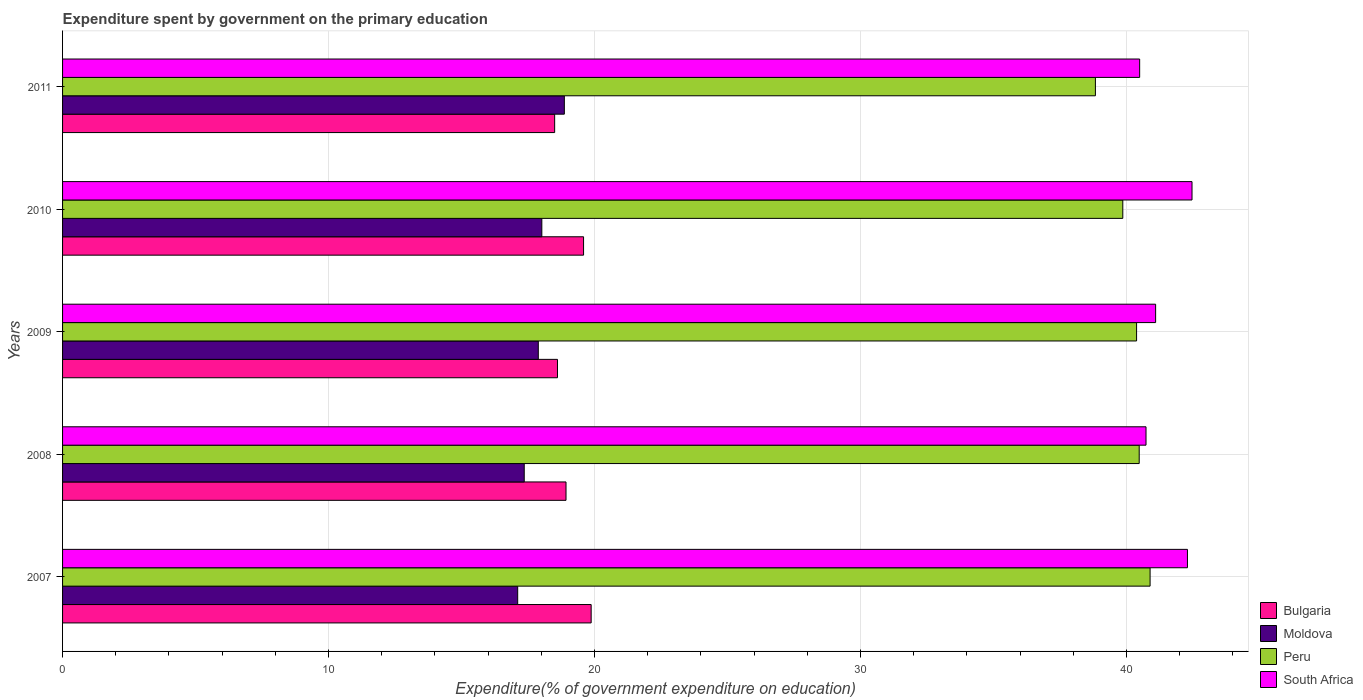How many groups of bars are there?
Give a very brief answer. 5. How many bars are there on the 2nd tick from the top?
Make the answer very short. 4. What is the expenditure spent by government on the primary education in South Africa in 2009?
Provide a short and direct response. 41.09. Across all years, what is the maximum expenditure spent by government on the primary education in South Africa?
Offer a very short reply. 42.46. Across all years, what is the minimum expenditure spent by government on the primary education in South Africa?
Your response must be concise. 40.49. In which year was the expenditure spent by government on the primary education in Moldova maximum?
Your answer should be compact. 2011. In which year was the expenditure spent by government on the primary education in Bulgaria minimum?
Provide a short and direct response. 2011. What is the total expenditure spent by government on the primary education in Peru in the graph?
Offer a terse response. 200.43. What is the difference between the expenditure spent by government on the primary education in Bulgaria in 2007 and that in 2009?
Give a very brief answer. 1.27. What is the difference between the expenditure spent by government on the primary education in Peru in 2009 and the expenditure spent by government on the primary education in Bulgaria in 2008?
Your answer should be very brief. 21.45. What is the average expenditure spent by government on the primary education in Peru per year?
Ensure brevity in your answer.  40.09. In the year 2011, what is the difference between the expenditure spent by government on the primary education in Moldova and expenditure spent by government on the primary education in Peru?
Make the answer very short. -19.97. What is the ratio of the expenditure spent by government on the primary education in South Africa in 2007 to that in 2011?
Keep it short and to the point. 1.04. Is the expenditure spent by government on the primary education in Moldova in 2007 less than that in 2008?
Ensure brevity in your answer.  Yes. Is the difference between the expenditure spent by government on the primary education in Moldova in 2009 and 2011 greater than the difference between the expenditure spent by government on the primary education in Peru in 2009 and 2011?
Provide a short and direct response. No. What is the difference between the highest and the second highest expenditure spent by government on the primary education in Bulgaria?
Give a very brief answer. 0.29. What is the difference between the highest and the lowest expenditure spent by government on the primary education in Moldova?
Your response must be concise. 1.75. What does the 4th bar from the top in 2008 represents?
Give a very brief answer. Bulgaria. What does the 4th bar from the bottom in 2011 represents?
Offer a terse response. South Africa. Is it the case that in every year, the sum of the expenditure spent by government on the primary education in Moldova and expenditure spent by government on the primary education in Peru is greater than the expenditure spent by government on the primary education in Bulgaria?
Make the answer very short. Yes. How many bars are there?
Provide a short and direct response. 20. Are all the bars in the graph horizontal?
Offer a very short reply. Yes. How many years are there in the graph?
Give a very brief answer. 5. What is the difference between two consecutive major ticks on the X-axis?
Offer a terse response. 10. Are the values on the major ticks of X-axis written in scientific E-notation?
Make the answer very short. No. Does the graph contain grids?
Make the answer very short. Yes. Where does the legend appear in the graph?
Your answer should be very brief. Bottom right. How are the legend labels stacked?
Offer a very short reply. Vertical. What is the title of the graph?
Your response must be concise. Expenditure spent by government on the primary education. What is the label or title of the X-axis?
Offer a terse response. Expenditure(% of government expenditure on education). What is the label or title of the Y-axis?
Your answer should be very brief. Years. What is the Expenditure(% of government expenditure on education) in Bulgaria in 2007?
Give a very brief answer. 19.87. What is the Expenditure(% of government expenditure on education) of Moldova in 2007?
Give a very brief answer. 17.11. What is the Expenditure(% of government expenditure on education) of Peru in 2007?
Your answer should be very brief. 40.89. What is the Expenditure(% of government expenditure on education) in South Africa in 2007?
Ensure brevity in your answer.  42.29. What is the Expenditure(% of government expenditure on education) of Bulgaria in 2008?
Ensure brevity in your answer.  18.93. What is the Expenditure(% of government expenditure on education) of Moldova in 2008?
Make the answer very short. 17.36. What is the Expenditure(% of government expenditure on education) of Peru in 2008?
Your answer should be compact. 40.48. What is the Expenditure(% of government expenditure on education) in South Africa in 2008?
Keep it short and to the point. 40.73. What is the Expenditure(% of government expenditure on education) of Bulgaria in 2009?
Ensure brevity in your answer.  18.61. What is the Expenditure(% of government expenditure on education) of Moldova in 2009?
Your response must be concise. 17.89. What is the Expenditure(% of government expenditure on education) of Peru in 2009?
Offer a terse response. 40.38. What is the Expenditure(% of government expenditure on education) in South Africa in 2009?
Provide a short and direct response. 41.09. What is the Expenditure(% of government expenditure on education) of Bulgaria in 2010?
Your response must be concise. 19.59. What is the Expenditure(% of government expenditure on education) in Moldova in 2010?
Your answer should be very brief. 18.02. What is the Expenditure(% of government expenditure on education) of Peru in 2010?
Provide a short and direct response. 39.86. What is the Expenditure(% of government expenditure on education) of South Africa in 2010?
Offer a very short reply. 42.46. What is the Expenditure(% of government expenditure on education) of Bulgaria in 2011?
Your response must be concise. 18.5. What is the Expenditure(% of government expenditure on education) of Moldova in 2011?
Provide a succinct answer. 18.87. What is the Expenditure(% of government expenditure on education) of Peru in 2011?
Ensure brevity in your answer.  38.83. What is the Expenditure(% of government expenditure on education) in South Africa in 2011?
Keep it short and to the point. 40.49. Across all years, what is the maximum Expenditure(% of government expenditure on education) in Bulgaria?
Your response must be concise. 19.87. Across all years, what is the maximum Expenditure(% of government expenditure on education) of Moldova?
Offer a very short reply. 18.87. Across all years, what is the maximum Expenditure(% of government expenditure on education) of Peru?
Provide a succinct answer. 40.89. Across all years, what is the maximum Expenditure(% of government expenditure on education) in South Africa?
Offer a terse response. 42.46. Across all years, what is the minimum Expenditure(% of government expenditure on education) in Bulgaria?
Offer a very short reply. 18.5. Across all years, what is the minimum Expenditure(% of government expenditure on education) in Moldova?
Your response must be concise. 17.11. Across all years, what is the minimum Expenditure(% of government expenditure on education) of Peru?
Ensure brevity in your answer.  38.83. Across all years, what is the minimum Expenditure(% of government expenditure on education) of South Africa?
Your response must be concise. 40.49. What is the total Expenditure(% of government expenditure on education) in Bulgaria in the graph?
Keep it short and to the point. 95.5. What is the total Expenditure(% of government expenditure on education) of Moldova in the graph?
Your response must be concise. 89.24. What is the total Expenditure(% of government expenditure on education) of Peru in the graph?
Offer a very short reply. 200.43. What is the total Expenditure(% of government expenditure on education) of South Africa in the graph?
Your answer should be compact. 207.08. What is the difference between the Expenditure(% of government expenditure on education) in Bulgaria in 2007 and that in 2008?
Give a very brief answer. 0.95. What is the difference between the Expenditure(% of government expenditure on education) of Moldova in 2007 and that in 2008?
Make the answer very short. -0.25. What is the difference between the Expenditure(% of government expenditure on education) in Peru in 2007 and that in 2008?
Provide a short and direct response. 0.41. What is the difference between the Expenditure(% of government expenditure on education) in South Africa in 2007 and that in 2008?
Make the answer very short. 1.56. What is the difference between the Expenditure(% of government expenditure on education) of Bulgaria in 2007 and that in 2009?
Provide a short and direct response. 1.27. What is the difference between the Expenditure(% of government expenditure on education) of Moldova in 2007 and that in 2009?
Provide a short and direct response. -0.77. What is the difference between the Expenditure(% of government expenditure on education) of Peru in 2007 and that in 2009?
Offer a terse response. 0.51. What is the difference between the Expenditure(% of government expenditure on education) of South Africa in 2007 and that in 2009?
Your response must be concise. 1.2. What is the difference between the Expenditure(% of government expenditure on education) in Bulgaria in 2007 and that in 2010?
Offer a terse response. 0.29. What is the difference between the Expenditure(% of government expenditure on education) of Moldova in 2007 and that in 2010?
Make the answer very short. -0.91. What is the difference between the Expenditure(% of government expenditure on education) of Peru in 2007 and that in 2010?
Provide a succinct answer. 1.03. What is the difference between the Expenditure(% of government expenditure on education) in South Africa in 2007 and that in 2010?
Offer a very short reply. -0.17. What is the difference between the Expenditure(% of government expenditure on education) of Bulgaria in 2007 and that in 2011?
Your answer should be very brief. 1.37. What is the difference between the Expenditure(% of government expenditure on education) in Moldova in 2007 and that in 2011?
Provide a succinct answer. -1.75. What is the difference between the Expenditure(% of government expenditure on education) of Peru in 2007 and that in 2011?
Your answer should be very brief. 2.06. What is the difference between the Expenditure(% of government expenditure on education) in South Africa in 2007 and that in 2011?
Provide a short and direct response. 1.8. What is the difference between the Expenditure(% of government expenditure on education) of Bulgaria in 2008 and that in 2009?
Your response must be concise. 0.32. What is the difference between the Expenditure(% of government expenditure on education) of Moldova in 2008 and that in 2009?
Provide a short and direct response. -0.53. What is the difference between the Expenditure(% of government expenditure on education) of Peru in 2008 and that in 2009?
Keep it short and to the point. 0.1. What is the difference between the Expenditure(% of government expenditure on education) of South Africa in 2008 and that in 2009?
Give a very brief answer. -0.36. What is the difference between the Expenditure(% of government expenditure on education) of Bulgaria in 2008 and that in 2010?
Make the answer very short. -0.66. What is the difference between the Expenditure(% of government expenditure on education) in Moldova in 2008 and that in 2010?
Ensure brevity in your answer.  -0.66. What is the difference between the Expenditure(% of government expenditure on education) in Peru in 2008 and that in 2010?
Provide a succinct answer. 0.62. What is the difference between the Expenditure(% of government expenditure on education) of South Africa in 2008 and that in 2010?
Your response must be concise. -1.73. What is the difference between the Expenditure(% of government expenditure on education) of Bulgaria in 2008 and that in 2011?
Offer a terse response. 0.43. What is the difference between the Expenditure(% of government expenditure on education) of Moldova in 2008 and that in 2011?
Provide a short and direct response. -1.51. What is the difference between the Expenditure(% of government expenditure on education) of Peru in 2008 and that in 2011?
Give a very brief answer. 1.65. What is the difference between the Expenditure(% of government expenditure on education) in South Africa in 2008 and that in 2011?
Offer a very short reply. 0.24. What is the difference between the Expenditure(% of government expenditure on education) of Bulgaria in 2009 and that in 2010?
Your answer should be very brief. -0.98. What is the difference between the Expenditure(% of government expenditure on education) in Moldova in 2009 and that in 2010?
Provide a succinct answer. -0.13. What is the difference between the Expenditure(% of government expenditure on education) of Peru in 2009 and that in 2010?
Make the answer very short. 0.52. What is the difference between the Expenditure(% of government expenditure on education) of South Africa in 2009 and that in 2010?
Your answer should be very brief. -1.37. What is the difference between the Expenditure(% of government expenditure on education) of Bulgaria in 2009 and that in 2011?
Make the answer very short. 0.11. What is the difference between the Expenditure(% of government expenditure on education) in Moldova in 2009 and that in 2011?
Your answer should be compact. -0.98. What is the difference between the Expenditure(% of government expenditure on education) of Peru in 2009 and that in 2011?
Keep it short and to the point. 1.55. What is the difference between the Expenditure(% of government expenditure on education) of South Africa in 2009 and that in 2011?
Provide a succinct answer. 0.6. What is the difference between the Expenditure(% of government expenditure on education) in Bulgaria in 2010 and that in 2011?
Keep it short and to the point. 1.09. What is the difference between the Expenditure(% of government expenditure on education) of Moldova in 2010 and that in 2011?
Offer a terse response. -0.85. What is the difference between the Expenditure(% of government expenditure on education) in Peru in 2010 and that in 2011?
Your answer should be very brief. 1.03. What is the difference between the Expenditure(% of government expenditure on education) in South Africa in 2010 and that in 2011?
Provide a short and direct response. 1.97. What is the difference between the Expenditure(% of government expenditure on education) of Bulgaria in 2007 and the Expenditure(% of government expenditure on education) of Moldova in 2008?
Your response must be concise. 2.52. What is the difference between the Expenditure(% of government expenditure on education) of Bulgaria in 2007 and the Expenditure(% of government expenditure on education) of Peru in 2008?
Make the answer very short. -20.6. What is the difference between the Expenditure(% of government expenditure on education) of Bulgaria in 2007 and the Expenditure(% of government expenditure on education) of South Africa in 2008?
Ensure brevity in your answer.  -20.86. What is the difference between the Expenditure(% of government expenditure on education) of Moldova in 2007 and the Expenditure(% of government expenditure on education) of Peru in 2008?
Give a very brief answer. -23.37. What is the difference between the Expenditure(% of government expenditure on education) in Moldova in 2007 and the Expenditure(% of government expenditure on education) in South Africa in 2008?
Make the answer very short. -23.62. What is the difference between the Expenditure(% of government expenditure on education) of Peru in 2007 and the Expenditure(% of government expenditure on education) of South Africa in 2008?
Provide a short and direct response. 0.15. What is the difference between the Expenditure(% of government expenditure on education) of Bulgaria in 2007 and the Expenditure(% of government expenditure on education) of Moldova in 2009?
Ensure brevity in your answer.  1.99. What is the difference between the Expenditure(% of government expenditure on education) in Bulgaria in 2007 and the Expenditure(% of government expenditure on education) in Peru in 2009?
Provide a succinct answer. -20.51. What is the difference between the Expenditure(% of government expenditure on education) of Bulgaria in 2007 and the Expenditure(% of government expenditure on education) of South Africa in 2009?
Keep it short and to the point. -21.22. What is the difference between the Expenditure(% of government expenditure on education) of Moldova in 2007 and the Expenditure(% of government expenditure on education) of Peru in 2009?
Provide a succinct answer. -23.27. What is the difference between the Expenditure(% of government expenditure on education) in Moldova in 2007 and the Expenditure(% of government expenditure on education) in South Africa in 2009?
Ensure brevity in your answer.  -23.98. What is the difference between the Expenditure(% of government expenditure on education) in Peru in 2007 and the Expenditure(% of government expenditure on education) in South Africa in 2009?
Ensure brevity in your answer.  -0.21. What is the difference between the Expenditure(% of government expenditure on education) of Bulgaria in 2007 and the Expenditure(% of government expenditure on education) of Moldova in 2010?
Ensure brevity in your answer.  1.85. What is the difference between the Expenditure(% of government expenditure on education) in Bulgaria in 2007 and the Expenditure(% of government expenditure on education) in Peru in 2010?
Make the answer very short. -19.99. What is the difference between the Expenditure(% of government expenditure on education) of Bulgaria in 2007 and the Expenditure(% of government expenditure on education) of South Africa in 2010?
Ensure brevity in your answer.  -22.59. What is the difference between the Expenditure(% of government expenditure on education) in Moldova in 2007 and the Expenditure(% of government expenditure on education) in Peru in 2010?
Give a very brief answer. -22.75. What is the difference between the Expenditure(% of government expenditure on education) in Moldova in 2007 and the Expenditure(% of government expenditure on education) in South Africa in 2010?
Your response must be concise. -25.35. What is the difference between the Expenditure(% of government expenditure on education) of Peru in 2007 and the Expenditure(% of government expenditure on education) of South Africa in 2010?
Ensure brevity in your answer.  -1.58. What is the difference between the Expenditure(% of government expenditure on education) of Bulgaria in 2007 and the Expenditure(% of government expenditure on education) of Peru in 2011?
Ensure brevity in your answer.  -18.96. What is the difference between the Expenditure(% of government expenditure on education) of Bulgaria in 2007 and the Expenditure(% of government expenditure on education) of South Africa in 2011?
Your answer should be compact. -20.62. What is the difference between the Expenditure(% of government expenditure on education) of Moldova in 2007 and the Expenditure(% of government expenditure on education) of Peru in 2011?
Make the answer very short. -21.72. What is the difference between the Expenditure(% of government expenditure on education) in Moldova in 2007 and the Expenditure(% of government expenditure on education) in South Africa in 2011?
Keep it short and to the point. -23.38. What is the difference between the Expenditure(% of government expenditure on education) in Peru in 2007 and the Expenditure(% of government expenditure on education) in South Africa in 2011?
Your answer should be very brief. 0.39. What is the difference between the Expenditure(% of government expenditure on education) in Bulgaria in 2008 and the Expenditure(% of government expenditure on education) in Moldova in 2009?
Your answer should be compact. 1.04. What is the difference between the Expenditure(% of government expenditure on education) in Bulgaria in 2008 and the Expenditure(% of government expenditure on education) in Peru in 2009?
Keep it short and to the point. -21.45. What is the difference between the Expenditure(% of government expenditure on education) in Bulgaria in 2008 and the Expenditure(% of government expenditure on education) in South Africa in 2009?
Offer a terse response. -22.17. What is the difference between the Expenditure(% of government expenditure on education) of Moldova in 2008 and the Expenditure(% of government expenditure on education) of Peru in 2009?
Ensure brevity in your answer.  -23.02. What is the difference between the Expenditure(% of government expenditure on education) of Moldova in 2008 and the Expenditure(% of government expenditure on education) of South Africa in 2009?
Your answer should be compact. -23.74. What is the difference between the Expenditure(% of government expenditure on education) of Peru in 2008 and the Expenditure(% of government expenditure on education) of South Africa in 2009?
Give a very brief answer. -0.62. What is the difference between the Expenditure(% of government expenditure on education) of Bulgaria in 2008 and the Expenditure(% of government expenditure on education) of Moldova in 2010?
Offer a terse response. 0.91. What is the difference between the Expenditure(% of government expenditure on education) in Bulgaria in 2008 and the Expenditure(% of government expenditure on education) in Peru in 2010?
Keep it short and to the point. -20.93. What is the difference between the Expenditure(% of government expenditure on education) of Bulgaria in 2008 and the Expenditure(% of government expenditure on education) of South Africa in 2010?
Your response must be concise. -23.54. What is the difference between the Expenditure(% of government expenditure on education) in Moldova in 2008 and the Expenditure(% of government expenditure on education) in Peru in 2010?
Give a very brief answer. -22.5. What is the difference between the Expenditure(% of government expenditure on education) in Moldova in 2008 and the Expenditure(% of government expenditure on education) in South Africa in 2010?
Keep it short and to the point. -25.11. What is the difference between the Expenditure(% of government expenditure on education) in Peru in 2008 and the Expenditure(% of government expenditure on education) in South Africa in 2010?
Ensure brevity in your answer.  -1.99. What is the difference between the Expenditure(% of government expenditure on education) in Bulgaria in 2008 and the Expenditure(% of government expenditure on education) in Moldova in 2011?
Provide a short and direct response. 0.06. What is the difference between the Expenditure(% of government expenditure on education) in Bulgaria in 2008 and the Expenditure(% of government expenditure on education) in Peru in 2011?
Offer a very short reply. -19.9. What is the difference between the Expenditure(% of government expenditure on education) of Bulgaria in 2008 and the Expenditure(% of government expenditure on education) of South Africa in 2011?
Make the answer very short. -21.57. What is the difference between the Expenditure(% of government expenditure on education) of Moldova in 2008 and the Expenditure(% of government expenditure on education) of Peru in 2011?
Ensure brevity in your answer.  -21.47. What is the difference between the Expenditure(% of government expenditure on education) of Moldova in 2008 and the Expenditure(% of government expenditure on education) of South Africa in 2011?
Provide a succinct answer. -23.14. What is the difference between the Expenditure(% of government expenditure on education) in Peru in 2008 and the Expenditure(% of government expenditure on education) in South Africa in 2011?
Offer a terse response. -0.02. What is the difference between the Expenditure(% of government expenditure on education) in Bulgaria in 2009 and the Expenditure(% of government expenditure on education) in Moldova in 2010?
Keep it short and to the point. 0.59. What is the difference between the Expenditure(% of government expenditure on education) of Bulgaria in 2009 and the Expenditure(% of government expenditure on education) of Peru in 2010?
Keep it short and to the point. -21.25. What is the difference between the Expenditure(% of government expenditure on education) of Bulgaria in 2009 and the Expenditure(% of government expenditure on education) of South Africa in 2010?
Your answer should be compact. -23.86. What is the difference between the Expenditure(% of government expenditure on education) in Moldova in 2009 and the Expenditure(% of government expenditure on education) in Peru in 2010?
Make the answer very short. -21.97. What is the difference between the Expenditure(% of government expenditure on education) of Moldova in 2009 and the Expenditure(% of government expenditure on education) of South Africa in 2010?
Ensure brevity in your answer.  -24.58. What is the difference between the Expenditure(% of government expenditure on education) in Peru in 2009 and the Expenditure(% of government expenditure on education) in South Africa in 2010?
Provide a succinct answer. -2.08. What is the difference between the Expenditure(% of government expenditure on education) of Bulgaria in 2009 and the Expenditure(% of government expenditure on education) of Moldova in 2011?
Make the answer very short. -0.26. What is the difference between the Expenditure(% of government expenditure on education) in Bulgaria in 2009 and the Expenditure(% of government expenditure on education) in Peru in 2011?
Provide a succinct answer. -20.22. What is the difference between the Expenditure(% of government expenditure on education) in Bulgaria in 2009 and the Expenditure(% of government expenditure on education) in South Africa in 2011?
Your answer should be compact. -21.89. What is the difference between the Expenditure(% of government expenditure on education) of Moldova in 2009 and the Expenditure(% of government expenditure on education) of Peru in 2011?
Your response must be concise. -20.94. What is the difference between the Expenditure(% of government expenditure on education) of Moldova in 2009 and the Expenditure(% of government expenditure on education) of South Africa in 2011?
Give a very brief answer. -22.61. What is the difference between the Expenditure(% of government expenditure on education) in Peru in 2009 and the Expenditure(% of government expenditure on education) in South Africa in 2011?
Your answer should be compact. -0.12. What is the difference between the Expenditure(% of government expenditure on education) of Bulgaria in 2010 and the Expenditure(% of government expenditure on education) of Moldova in 2011?
Offer a terse response. 0.72. What is the difference between the Expenditure(% of government expenditure on education) in Bulgaria in 2010 and the Expenditure(% of government expenditure on education) in Peru in 2011?
Your answer should be compact. -19.24. What is the difference between the Expenditure(% of government expenditure on education) of Bulgaria in 2010 and the Expenditure(% of government expenditure on education) of South Africa in 2011?
Keep it short and to the point. -20.91. What is the difference between the Expenditure(% of government expenditure on education) in Moldova in 2010 and the Expenditure(% of government expenditure on education) in Peru in 2011?
Give a very brief answer. -20.81. What is the difference between the Expenditure(% of government expenditure on education) in Moldova in 2010 and the Expenditure(% of government expenditure on education) in South Africa in 2011?
Your answer should be compact. -22.48. What is the difference between the Expenditure(% of government expenditure on education) of Peru in 2010 and the Expenditure(% of government expenditure on education) of South Africa in 2011?
Offer a very short reply. -0.63. What is the average Expenditure(% of government expenditure on education) in Bulgaria per year?
Give a very brief answer. 19.1. What is the average Expenditure(% of government expenditure on education) in Moldova per year?
Keep it short and to the point. 17.85. What is the average Expenditure(% of government expenditure on education) in Peru per year?
Make the answer very short. 40.09. What is the average Expenditure(% of government expenditure on education) in South Africa per year?
Your answer should be compact. 41.42. In the year 2007, what is the difference between the Expenditure(% of government expenditure on education) of Bulgaria and Expenditure(% of government expenditure on education) of Moldova?
Give a very brief answer. 2.76. In the year 2007, what is the difference between the Expenditure(% of government expenditure on education) of Bulgaria and Expenditure(% of government expenditure on education) of Peru?
Provide a succinct answer. -21.01. In the year 2007, what is the difference between the Expenditure(% of government expenditure on education) of Bulgaria and Expenditure(% of government expenditure on education) of South Africa?
Ensure brevity in your answer.  -22.42. In the year 2007, what is the difference between the Expenditure(% of government expenditure on education) in Moldova and Expenditure(% of government expenditure on education) in Peru?
Provide a succinct answer. -23.78. In the year 2007, what is the difference between the Expenditure(% of government expenditure on education) of Moldova and Expenditure(% of government expenditure on education) of South Africa?
Offer a very short reply. -25.18. In the year 2007, what is the difference between the Expenditure(% of government expenditure on education) in Peru and Expenditure(% of government expenditure on education) in South Africa?
Make the answer very short. -1.41. In the year 2008, what is the difference between the Expenditure(% of government expenditure on education) of Bulgaria and Expenditure(% of government expenditure on education) of Moldova?
Make the answer very short. 1.57. In the year 2008, what is the difference between the Expenditure(% of government expenditure on education) in Bulgaria and Expenditure(% of government expenditure on education) in Peru?
Make the answer very short. -21.55. In the year 2008, what is the difference between the Expenditure(% of government expenditure on education) of Bulgaria and Expenditure(% of government expenditure on education) of South Africa?
Your response must be concise. -21.81. In the year 2008, what is the difference between the Expenditure(% of government expenditure on education) in Moldova and Expenditure(% of government expenditure on education) in Peru?
Make the answer very short. -23.12. In the year 2008, what is the difference between the Expenditure(% of government expenditure on education) in Moldova and Expenditure(% of government expenditure on education) in South Africa?
Keep it short and to the point. -23.38. In the year 2008, what is the difference between the Expenditure(% of government expenditure on education) in Peru and Expenditure(% of government expenditure on education) in South Africa?
Ensure brevity in your answer.  -0.26. In the year 2009, what is the difference between the Expenditure(% of government expenditure on education) of Bulgaria and Expenditure(% of government expenditure on education) of Moldova?
Your response must be concise. 0.72. In the year 2009, what is the difference between the Expenditure(% of government expenditure on education) of Bulgaria and Expenditure(% of government expenditure on education) of Peru?
Give a very brief answer. -21.77. In the year 2009, what is the difference between the Expenditure(% of government expenditure on education) of Bulgaria and Expenditure(% of government expenditure on education) of South Africa?
Your answer should be very brief. -22.49. In the year 2009, what is the difference between the Expenditure(% of government expenditure on education) in Moldova and Expenditure(% of government expenditure on education) in Peru?
Your answer should be compact. -22.49. In the year 2009, what is the difference between the Expenditure(% of government expenditure on education) of Moldova and Expenditure(% of government expenditure on education) of South Africa?
Offer a terse response. -23.21. In the year 2009, what is the difference between the Expenditure(% of government expenditure on education) in Peru and Expenditure(% of government expenditure on education) in South Africa?
Offer a terse response. -0.72. In the year 2010, what is the difference between the Expenditure(% of government expenditure on education) in Bulgaria and Expenditure(% of government expenditure on education) in Moldova?
Your answer should be very brief. 1.57. In the year 2010, what is the difference between the Expenditure(% of government expenditure on education) of Bulgaria and Expenditure(% of government expenditure on education) of Peru?
Provide a short and direct response. -20.27. In the year 2010, what is the difference between the Expenditure(% of government expenditure on education) in Bulgaria and Expenditure(% of government expenditure on education) in South Africa?
Provide a succinct answer. -22.88. In the year 2010, what is the difference between the Expenditure(% of government expenditure on education) of Moldova and Expenditure(% of government expenditure on education) of Peru?
Your answer should be very brief. -21.84. In the year 2010, what is the difference between the Expenditure(% of government expenditure on education) of Moldova and Expenditure(% of government expenditure on education) of South Africa?
Give a very brief answer. -24.44. In the year 2010, what is the difference between the Expenditure(% of government expenditure on education) in Peru and Expenditure(% of government expenditure on education) in South Africa?
Your answer should be very brief. -2.6. In the year 2011, what is the difference between the Expenditure(% of government expenditure on education) in Bulgaria and Expenditure(% of government expenditure on education) in Moldova?
Your answer should be compact. -0.36. In the year 2011, what is the difference between the Expenditure(% of government expenditure on education) in Bulgaria and Expenditure(% of government expenditure on education) in Peru?
Your answer should be very brief. -20.33. In the year 2011, what is the difference between the Expenditure(% of government expenditure on education) of Bulgaria and Expenditure(% of government expenditure on education) of South Africa?
Keep it short and to the point. -21.99. In the year 2011, what is the difference between the Expenditure(% of government expenditure on education) in Moldova and Expenditure(% of government expenditure on education) in Peru?
Keep it short and to the point. -19.97. In the year 2011, what is the difference between the Expenditure(% of government expenditure on education) of Moldova and Expenditure(% of government expenditure on education) of South Africa?
Provide a succinct answer. -21.63. In the year 2011, what is the difference between the Expenditure(% of government expenditure on education) of Peru and Expenditure(% of government expenditure on education) of South Africa?
Offer a very short reply. -1.66. What is the ratio of the Expenditure(% of government expenditure on education) in Bulgaria in 2007 to that in 2008?
Provide a short and direct response. 1.05. What is the ratio of the Expenditure(% of government expenditure on education) in Moldova in 2007 to that in 2008?
Make the answer very short. 0.99. What is the ratio of the Expenditure(% of government expenditure on education) of South Africa in 2007 to that in 2008?
Give a very brief answer. 1.04. What is the ratio of the Expenditure(% of government expenditure on education) of Bulgaria in 2007 to that in 2009?
Provide a short and direct response. 1.07. What is the ratio of the Expenditure(% of government expenditure on education) in Moldova in 2007 to that in 2009?
Keep it short and to the point. 0.96. What is the ratio of the Expenditure(% of government expenditure on education) in Peru in 2007 to that in 2009?
Offer a terse response. 1.01. What is the ratio of the Expenditure(% of government expenditure on education) in South Africa in 2007 to that in 2009?
Give a very brief answer. 1.03. What is the ratio of the Expenditure(% of government expenditure on education) in Bulgaria in 2007 to that in 2010?
Offer a terse response. 1.01. What is the ratio of the Expenditure(% of government expenditure on education) in Moldova in 2007 to that in 2010?
Ensure brevity in your answer.  0.95. What is the ratio of the Expenditure(% of government expenditure on education) of Peru in 2007 to that in 2010?
Offer a very short reply. 1.03. What is the ratio of the Expenditure(% of government expenditure on education) of Bulgaria in 2007 to that in 2011?
Make the answer very short. 1.07. What is the ratio of the Expenditure(% of government expenditure on education) in Moldova in 2007 to that in 2011?
Your answer should be very brief. 0.91. What is the ratio of the Expenditure(% of government expenditure on education) of Peru in 2007 to that in 2011?
Your answer should be very brief. 1.05. What is the ratio of the Expenditure(% of government expenditure on education) in South Africa in 2007 to that in 2011?
Offer a very short reply. 1.04. What is the ratio of the Expenditure(% of government expenditure on education) in Bulgaria in 2008 to that in 2009?
Offer a very short reply. 1.02. What is the ratio of the Expenditure(% of government expenditure on education) in Moldova in 2008 to that in 2009?
Give a very brief answer. 0.97. What is the ratio of the Expenditure(% of government expenditure on education) of Peru in 2008 to that in 2009?
Offer a terse response. 1. What is the ratio of the Expenditure(% of government expenditure on education) in Bulgaria in 2008 to that in 2010?
Make the answer very short. 0.97. What is the ratio of the Expenditure(% of government expenditure on education) of Moldova in 2008 to that in 2010?
Your answer should be very brief. 0.96. What is the ratio of the Expenditure(% of government expenditure on education) of Peru in 2008 to that in 2010?
Provide a short and direct response. 1.02. What is the ratio of the Expenditure(% of government expenditure on education) in South Africa in 2008 to that in 2010?
Provide a succinct answer. 0.96. What is the ratio of the Expenditure(% of government expenditure on education) in Bulgaria in 2008 to that in 2011?
Your answer should be compact. 1.02. What is the ratio of the Expenditure(% of government expenditure on education) of Peru in 2008 to that in 2011?
Offer a terse response. 1.04. What is the ratio of the Expenditure(% of government expenditure on education) of South Africa in 2008 to that in 2011?
Your answer should be very brief. 1.01. What is the ratio of the Expenditure(% of government expenditure on education) in Bulgaria in 2009 to that in 2010?
Keep it short and to the point. 0.95. What is the ratio of the Expenditure(% of government expenditure on education) in Moldova in 2009 to that in 2010?
Keep it short and to the point. 0.99. What is the ratio of the Expenditure(% of government expenditure on education) in South Africa in 2009 to that in 2010?
Provide a succinct answer. 0.97. What is the ratio of the Expenditure(% of government expenditure on education) in Bulgaria in 2009 to that in 2011?
Make the answer very short. 1.01. What is the ratio of the Expenditure(% of government expenditure on education) in Moldova in 2009 to that in 2011?
Keep it short and to the point. 0.95. What is the ratio of the Expenditure(% of government expenditure on education) of Peru in 2009 to that in 2011?
Offer a terse response. 1.04. What is the ratio of the Expenditure(% of government expenditure on education) in South Africa in 2009 to that in 2011?
Your answer should be very brief. 1.01. What is the ratio of the Expenditure(% of government expenditure on education) of Bulgaria in 2010 to that in 2011?
Keep it short and to the point. 1.06. What is the ratio of the Expenditure(% of government expenditure on education) in Moldova in 2010 to that in 2011?
Offer a terse response. 0.96. What is the ratio of the Expenditure(% of government expenditure on education) of Peru in 2010 to that in 2011?
Your answer should be very brief. 1.03. What is the ratio of the Expenditure(% of government expenditure on education) of South Africa in 2010 to that in 2011?
Keep it short and to the point. 1.05. What is the difference between the highest and the second highest Expenditure(% of government expenditure on education) in Bulgaria?
Make the answer very short. 0.29. What is the difference between the highest and the second highest Expenditure(% of government expenditure on education) in Moldova?
Keep it short and to the point. 0.85. What is the difference between the highest and the second highest Expenditure(% of government expenditure on education) of Peru?
Give a very brief answer. 0.41. What is the difference between the highest and the second highest Expenditure(% of government expenditure on education) of South Africa?
Offer a very short reply. 0.17. What is the difference between the highest and the lowest Expenditure(% of government expenditure on education) in Bulgaria?
Provide a short and direct response. 1.37. What is the difference between the highest and the lowest Expenditure(% of government expenditure on education) of Moldova?
Provide a succinct answer. 1.75. What is the difference between the highest and the lowest Expenditure(% of government expenditure on education) of Peru?
Make the answer very short. 2.06. What is the difference between the highest and the lowest Expenditure(% of government expenditure on education) of South Africa?
Provide a short and direct response. 1.97. 